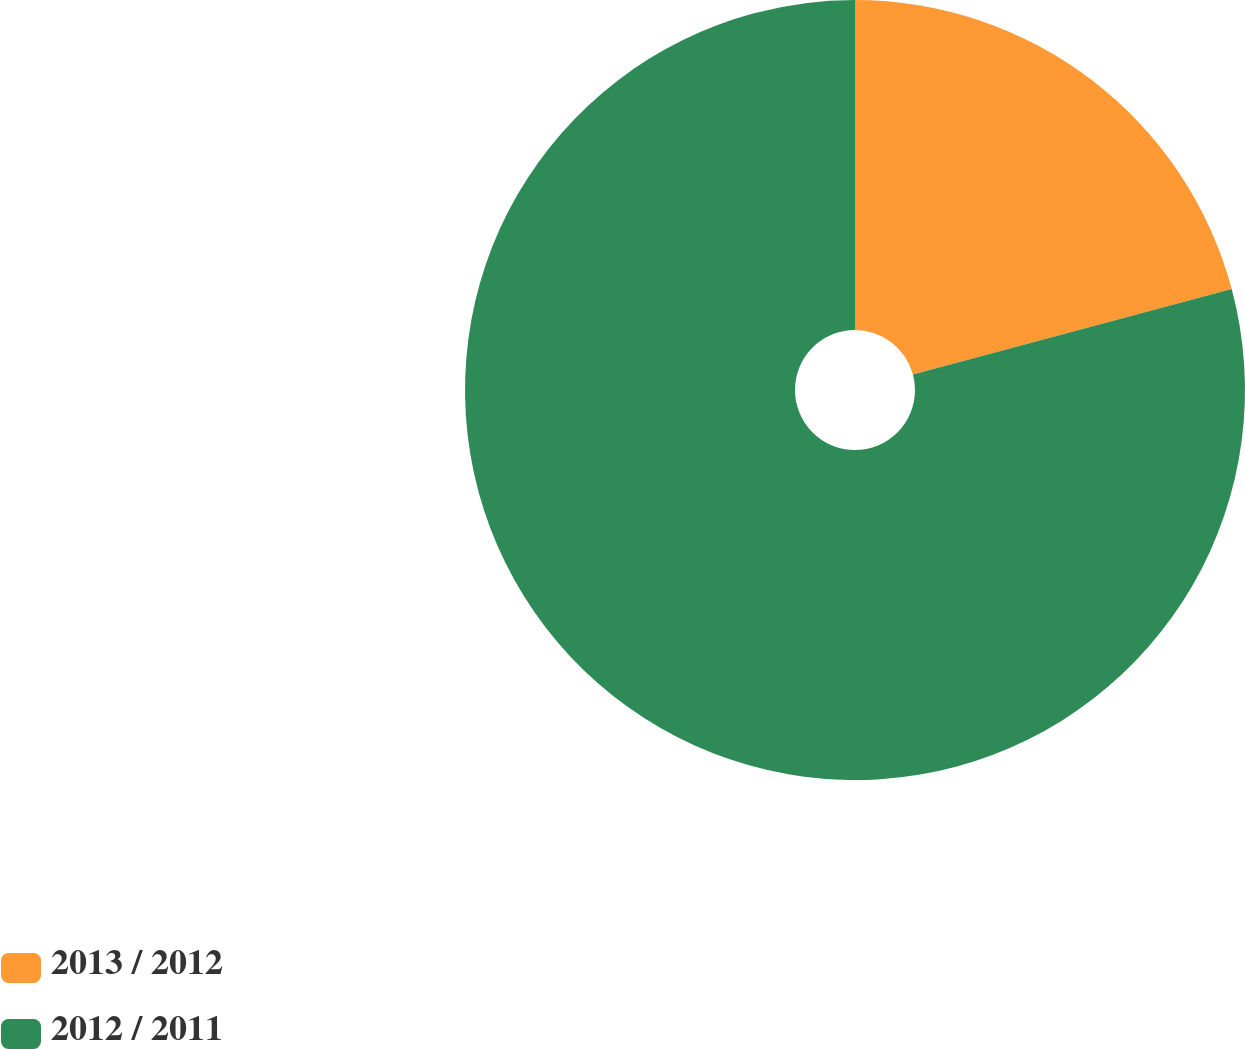<chart> <loc_0><loc_0><loc_500><loc_500><pie_chart><fcel>2013 / 2012<fcel>2012 / 2011<nl><fcel>20.83%<fcel>79.17%<nl></chart> 